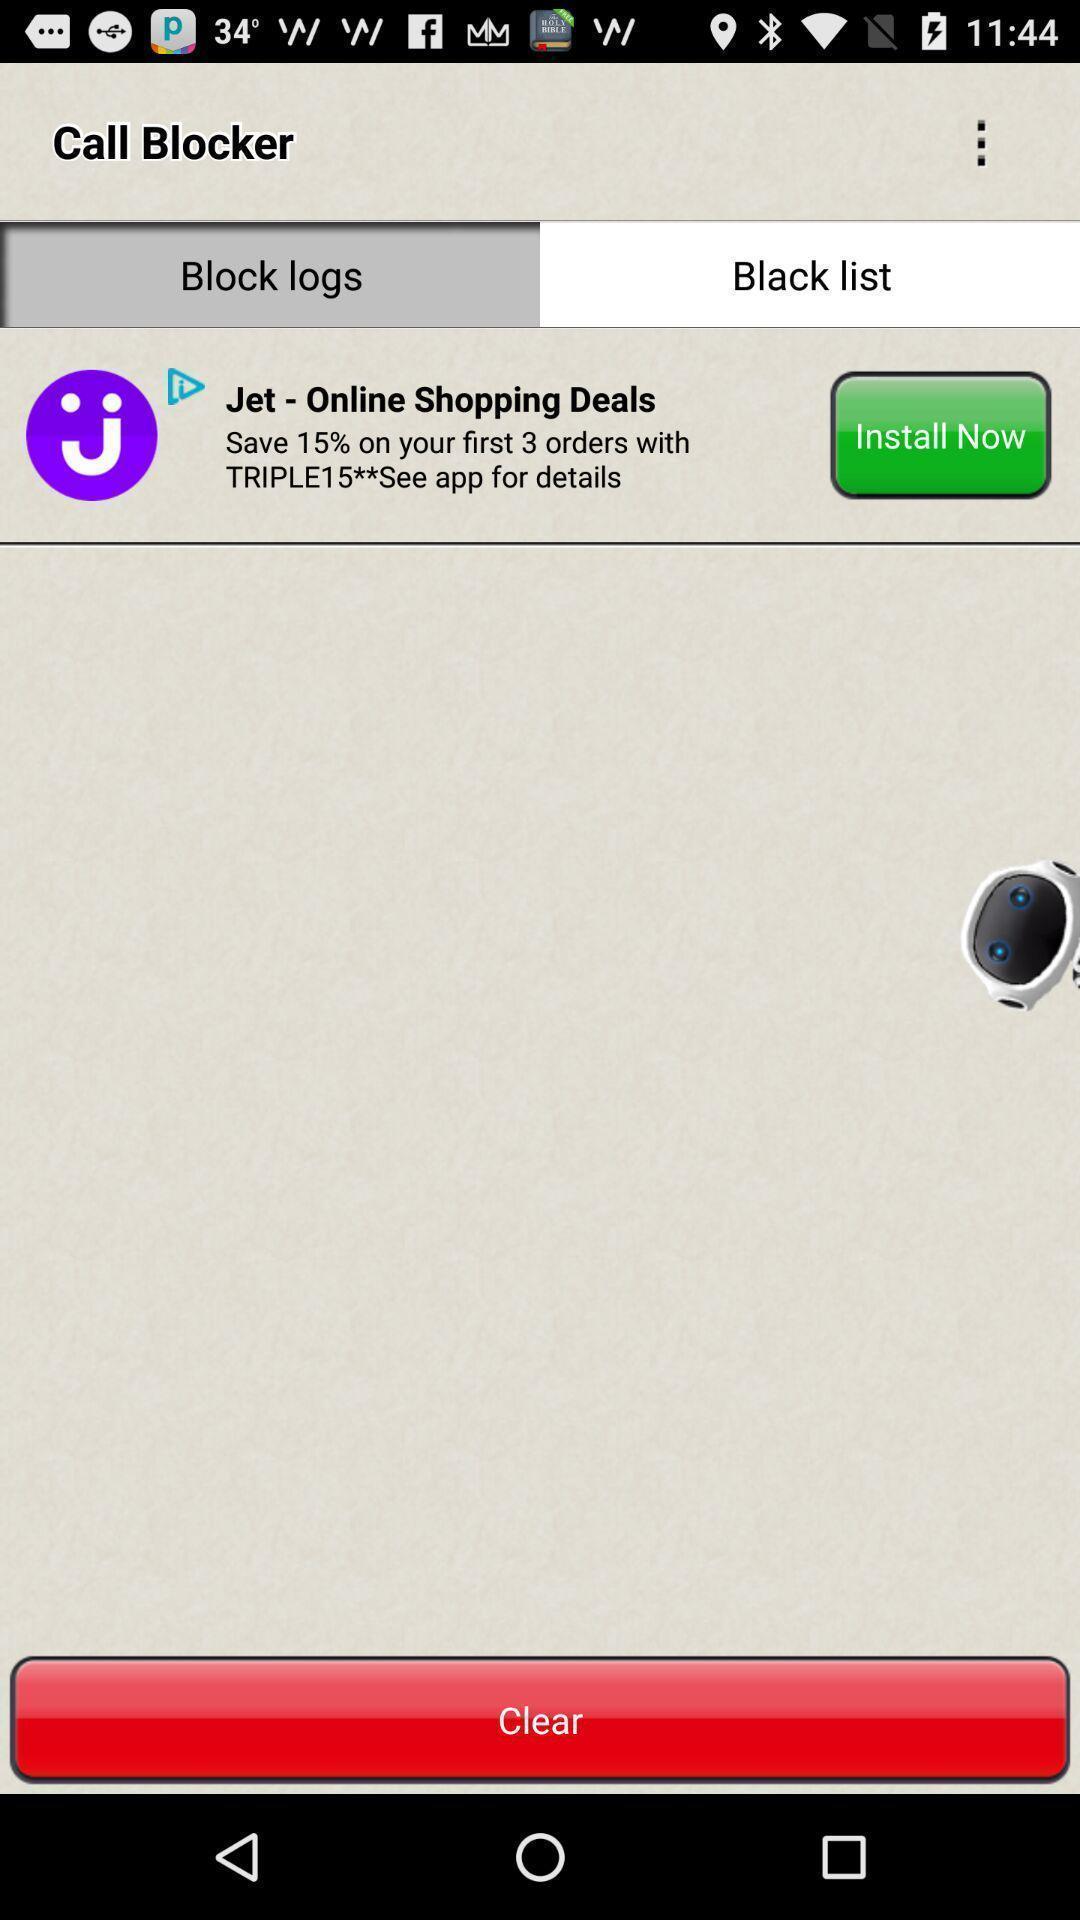Tell me what you see in this picture. Screen displaying black list page. 